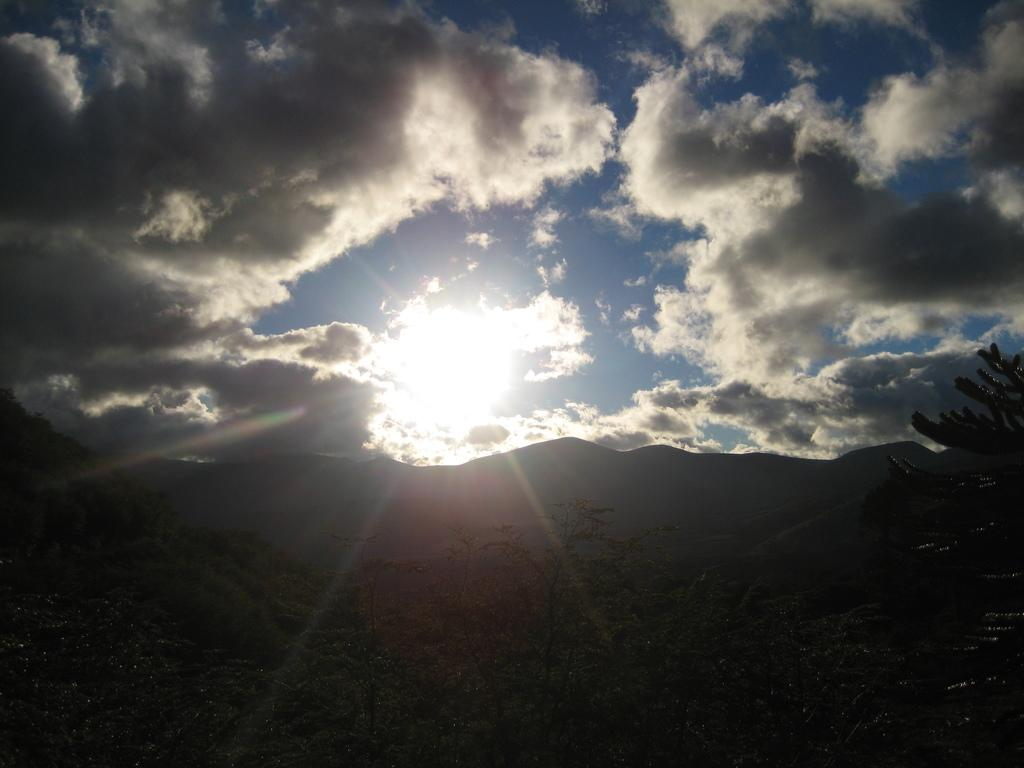What is located at the bottom of the image? There is a tree at the bottom of the image. What can be seen in the background of the image? There are mountains in the background of the image. What is visible in the sky in the image? The sun is visible in the sky, and there are clouds present as well. What type of milk is being exchanged between the mountains in the image? There is no exchange of milk or any other substance depicted in the image; it features a tree, mountains, the sun, and clouds. What is the temper of the clouds in the image? The image does not provide information about the temper of the clouds, as clouds do not have emotions or temperament. 